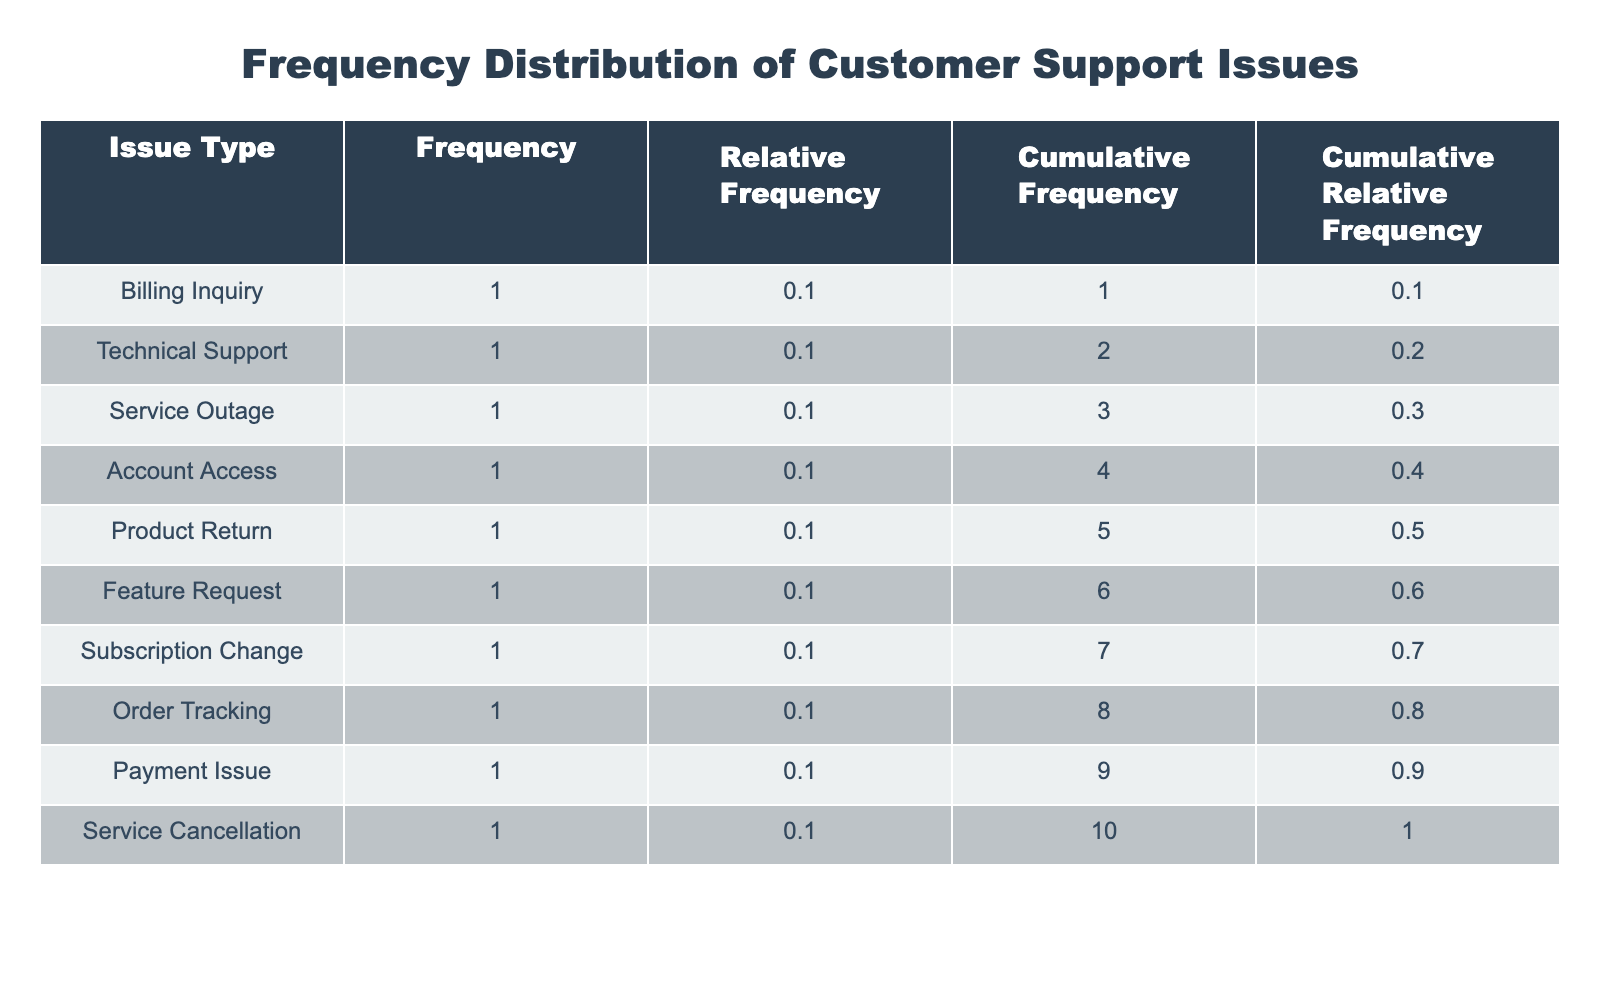What is the most frequent issue type reported? The table lists the frequency of each issue type. By examining the "Frequency" column, we can see that "Billing Inquiry," "Account Access," and "Order Tracking" each have the highest frequency of 1 incident, making them the most frequent issue types reported.
Answer: Billing Inquiry, Account Access, Order Tracking What is the cumulative frequency for "Technical Support"? The cumulative frequency for "Technical Support" includes the frequencies of all issue types up to and including "Technical Support". From the table, "Billing Inquiry" has a frequency of 1, "Account Access" has 1, and "Technical Support" has 1. Therefore, the cumulative frequency is 1 (Billing) + 1 (Account Access) + 1 (Technical Support) = 3.
Answer: 3 How many issues took longer than 3 hours to resolve? From the table, we identify the issue types with a resolution time greater than 3 hours. Only "Feature Request" with a resolution time of 5 hours is greater than 3 hours. Therefore, we count just this one issue.
Answer: 1 What is the average resolution time for all reported issues? To calculate the average resolution time, we sum all the resolution times: 1 + 2 + 4 + 1 + 3 + 5 + 2 + 1 + 2 + 3 = 24 hours. There are 10 issues in total. Dividing the total time by the number of issues gives: 24 / 10 = 2.4 hours.
Answer: 2.4 hours Is there a resolution time of exactly 2 hours for any issue type? Looking at the "Resolution Time" column, we can see that "Technical Support", "Subscription Change," and "Payment Issue" all have a resolution time of 2 hours. Thus, the statement is true.
Answer: Yes What are the cumulative relative frequencies for the first three issues? The cumulative relative frequency is calculated by summing the relative frequency of the issue types sequentially. Assuming the first three issue types (in the frequency list) are "Billing Inquiry," "Account Access," and "Order Tracking," we need their individual relative frequencies. If their frequencies are 1 each and the total frequency is 10, each relative frequency = 1/10 = 0.1. Therefore, summing these gives: 0.1 (Billing Inquiry) + 0.1 (Account Access) + 0.1 (Order Tracking) = 0.3.
Answer: 0.3 Which issue type has the highest resolution time? From the table, the issue type with the highest resolution time is "Feature Request," which takes 5 hours to resolve, as indicated in the "Resolution Time" column.
Answer: Feature Request How many total distinct issue types were reported? The distinct issue types can be counted in the "Issue Type" column. From the data provided, there are 10 unique types of issues reported as listed in the table, with no repetitions. Thus, there are 10 distinct issue types.
Answer: 10 